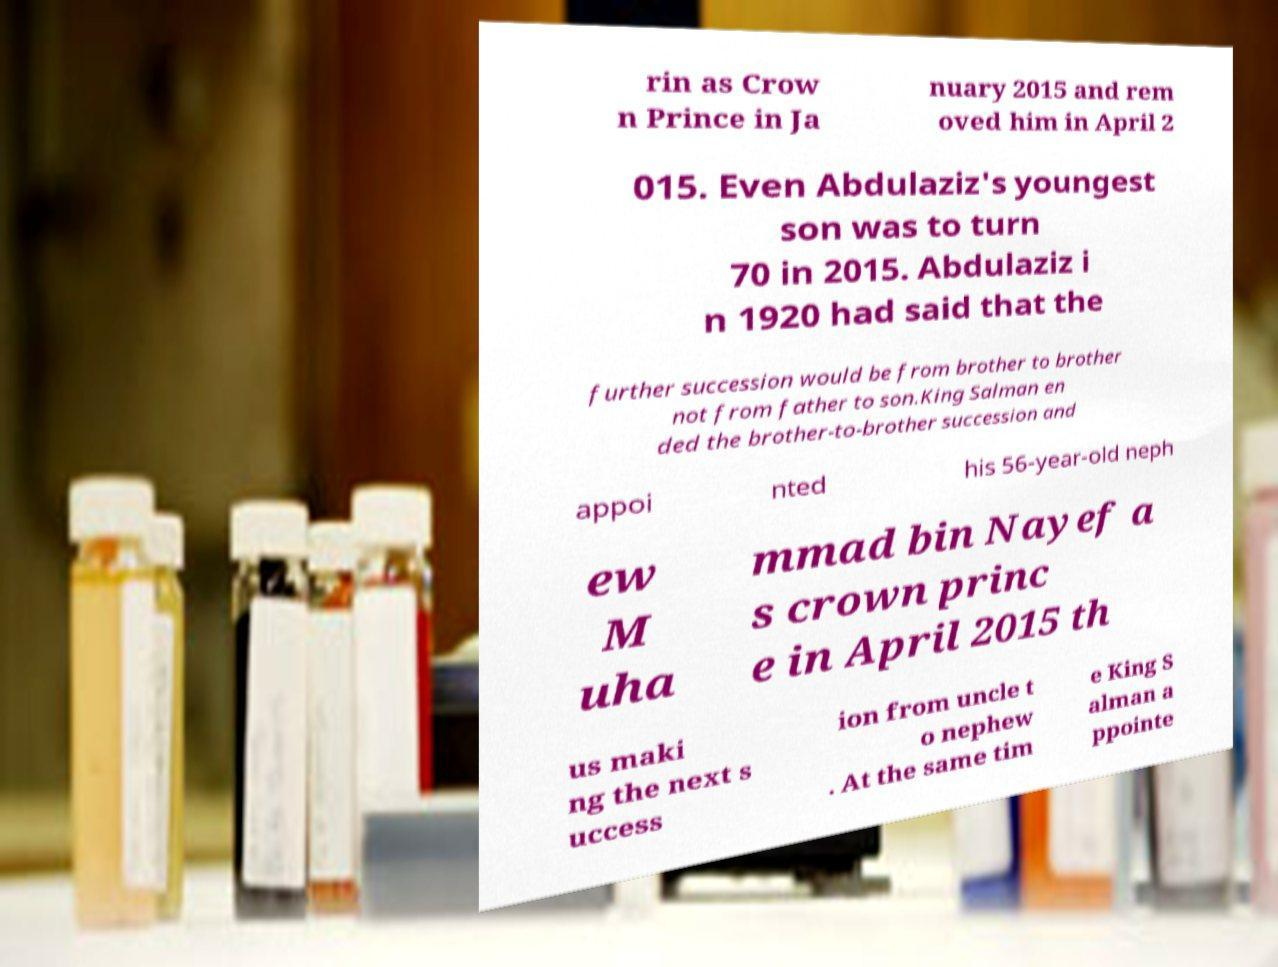Please read and relay the text visible in this image. What does it say? rin as Crow n Prince in Ja nuary 2015 and rem oved him in April 2 015. Even Abdulaziz's youngest son was to turn 70 in 2015. Abdulaziz i n 1920 had said that the further succession would be from brother to brother not from father to son.King Salman en ded the brother-to-brother succession and appoi nted his 56-year-old neph ew M uha mmad bin Nayef a s crown princ e in April 2015 th us maki ng the next s uccess ion from uncle t o nephew . At the same tim e King S alman a ppointe 